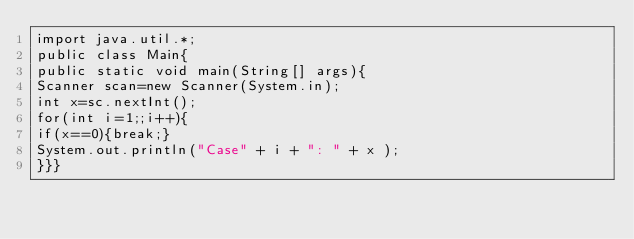<code> <loc_0><loc_0><loc_500><loc_500><_Java_>import java.util.*;
public class Main{
public static void main(String[] args){
Scanner scan=new Scanner(System.in);
int x=sc.nextInt();
for(int i=1;;i++){
if(x==0){break;}
System.out.println("Case" + i + ": " + x );
}}}</code> 